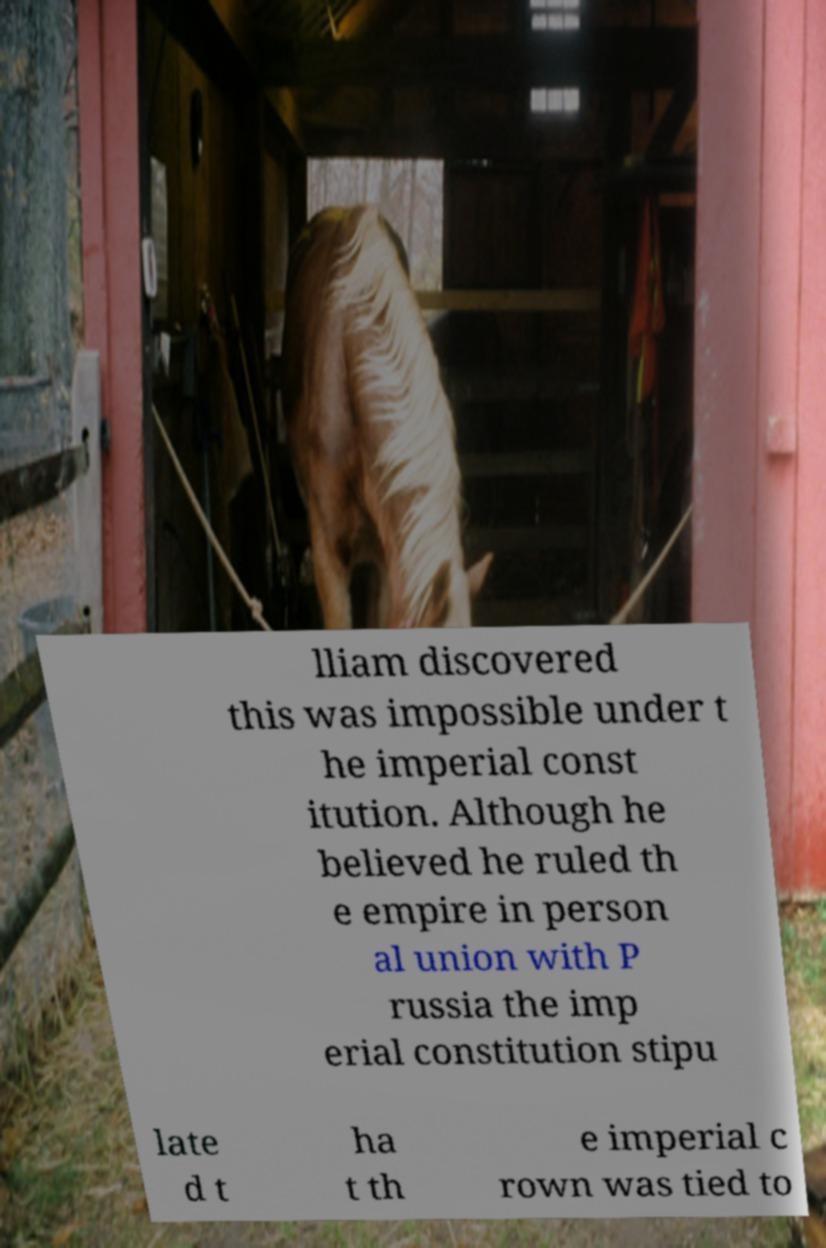Please identify and transcribe the text found in this image. lliam discovered this was impossible under t he imperial const itution. Although he believed he ruled th e empire in person al union with P russia the imp erial constitution stipu late d t ha t th e imperial c rown was tied to 